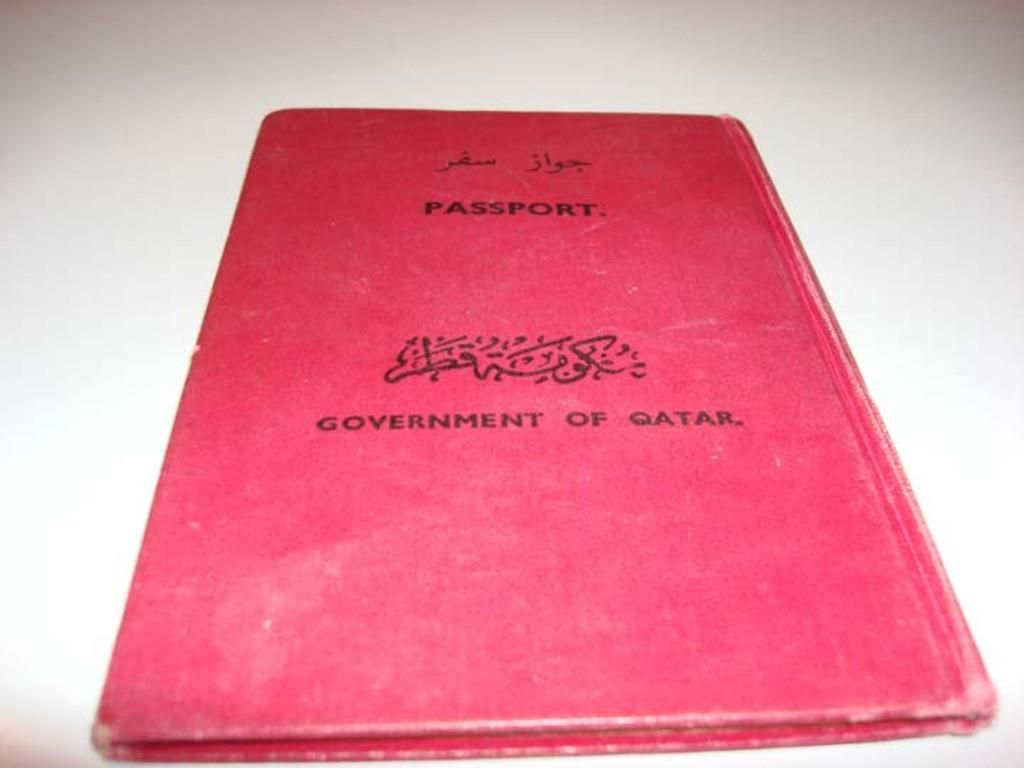<image>
Summarize the visual content of the image. The front red cover of a Qatar passport. 